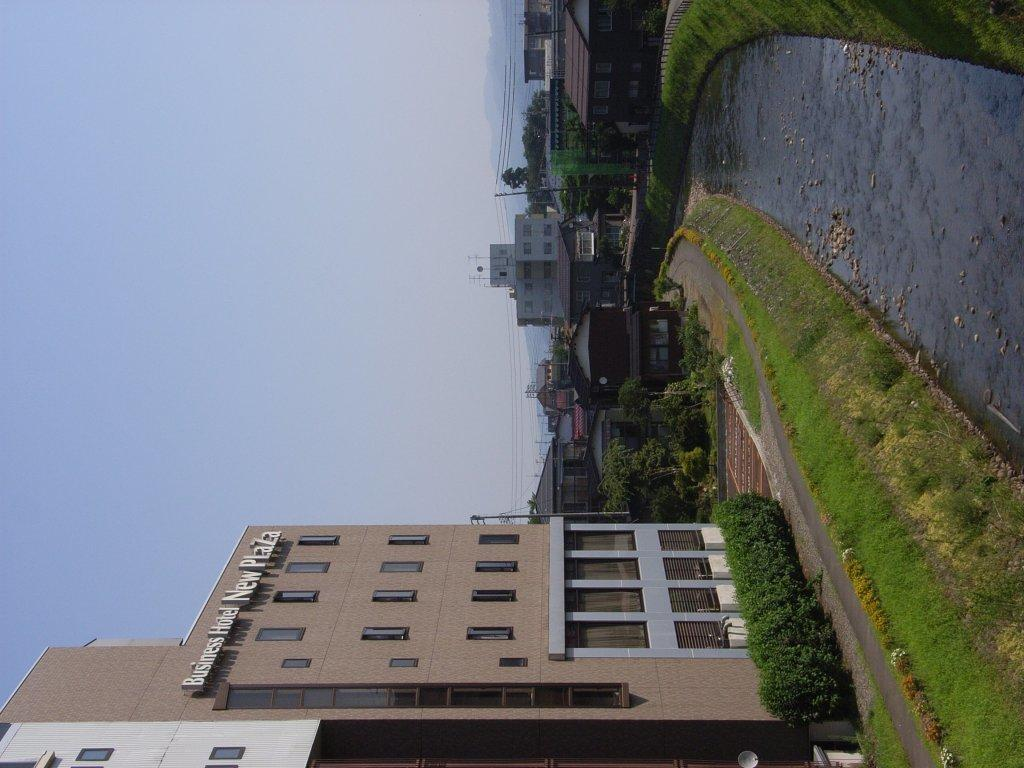What type of structures can be seen in the image? There are buildings in the image. What natural or man-made feature is on the right side of the image? There is a canal on the right side of the image. What is visible on the left side of the image? There is a sky visible on the left side of the image. What type of stage can be seen in the image? There is no stage present in the image. What sound can be heard coming from the canal in the image? There is no sound present in the image, as it is a still image. 